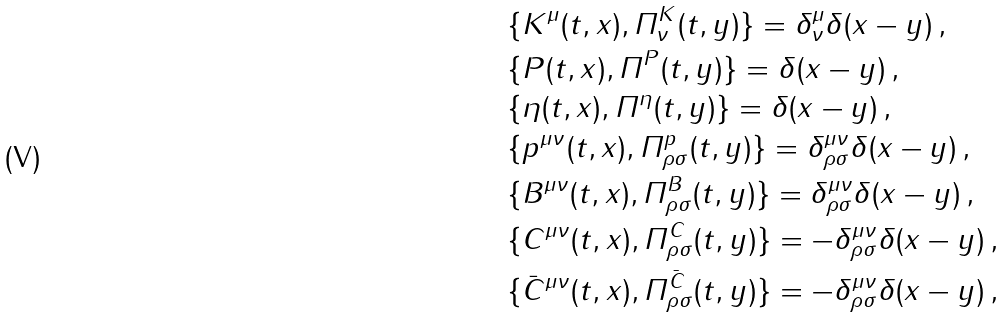Convert formula to latex. <formula><loc_0><loc_0><loc_500><loc_500>& \{ K ^ { \mu } ( t , x ) , \varPi ^ { K } _ { \nu } ( t , y ) \} = \delta ^ { \mu } _ { \nu } \delta ( x - y ) \, , \\ & \{ P ( t , x ) , \varPi ^ { P } ( t , y ) \} = \delta ( x - y ) \, , \\ & \{ \eta ( t , x ) , \varPi ^ { \eta } ( t , y ) \} = \delta ( x - y ) \, , \\ & \{ p ^ { \mu \nu } ( t , x ) , \varPi ^ { p } _ { \rho \sigma } ( t , y ) \} = \delta ^ { \mu \nu } _ { \rho \sigma } \delta ( x - y ) \, , \\ & \{ B ^ { \mu \nu } ( t , x ) , \varPi ^ { B } _ { \rho \sigma } ( t , y ) \} = \delta ^ { \mu \nu } _ { \rho \sigma } \delta ( x - y ) \, , \\ & \{ C ^ { \mu \nu } ( t , x ) , \varPi ^ { C } _ { \rho \sigma } ( t , y ) \} = - \delta ^ { \mu \nu } _ { \rho \sigma } \delta ( x - y ) \, , \\ & \{ \bar { C } ^ { \mu \nu } ( t , x ) , \varPi ^ { \bar { C } } _ { \rho \sigma } ( t , y ) \} = - \delta ^ { \mu \nu } _ { \rho \sigma } \delta ( x - y ) \, ,</formula> 